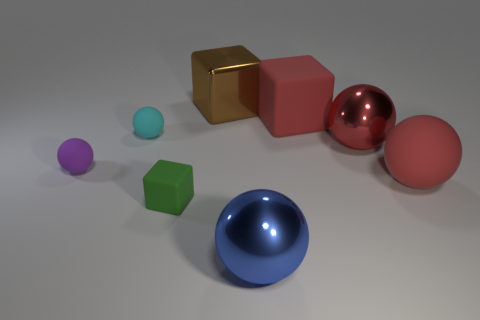Subtract all big metallic blocks. How many blocks are left? 2 Add 1 large gray metal things. How many objects exist? 9 Subtract all blue cubes. How many red spheres are left? 2 Subtract 1 cubes. How many cubes are left? 2 Subtract all red blocks. How many blocks are left? 2 Subtract all balls. How many objects are left? 3 Subtract all purple blocks. Subtract all green spheres. How many blocks are left? 3 Subtract all big things. Subtract all purple rubber cubes. How many objects are left? 3 Add 2 metallic balls. How many metallic balls are left? 4 Add 2 green blocks. How many green blocks exist? 3 